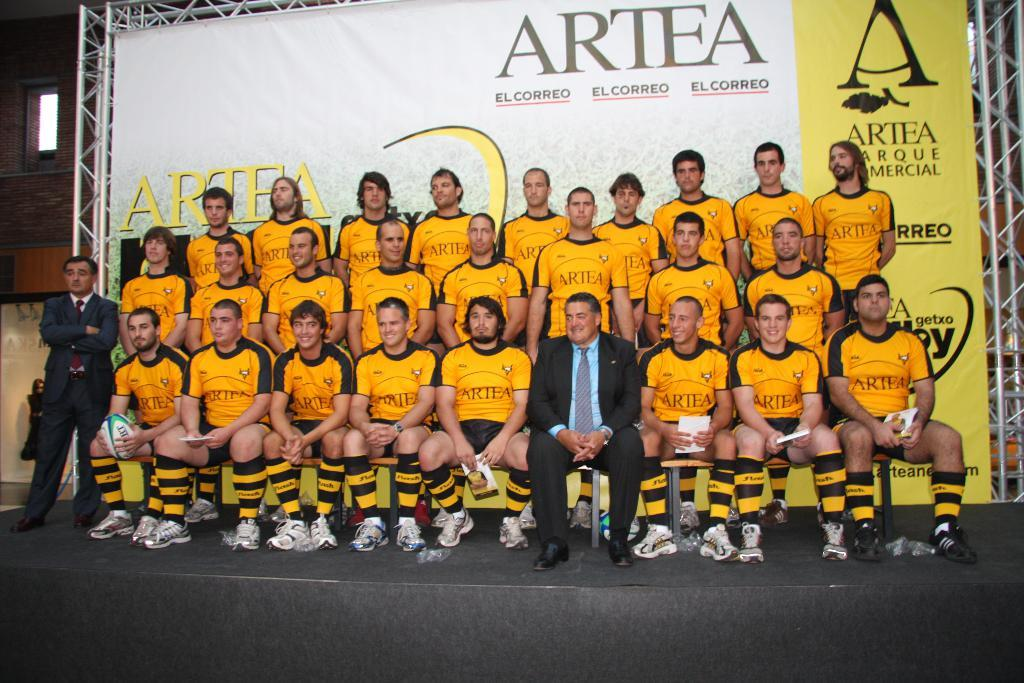What are the people in the image doing? There are people sitting on a bench and standing in the image. What can be seen in the background of the image? There is a banner in the background of the image. What is written on the banner? There is text on the banner. What type of structure is present in the image? There is a metal frame in the image. How does the jar help the mom in the image? There is no jar or mom present in the image. 